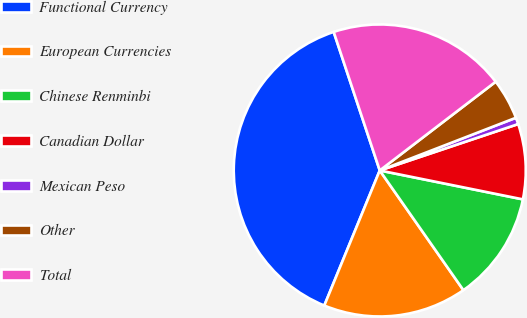<chart> <loc_0><loc_0><loc_500><loc_500><pie_chart><fcel>Functional Currency<fcel>European Currencies<fcel>Chinese Renminbi<fcel>Canadian Dollar<fcel>Mexican Peso<fcel>Other<fcel>Total<nl><fcel>38.69%<fcel>15.91%<fcel>12.12%<fcel>8.32%<fcel>0.73%<fcel>4.52%<fcel>19.71%<nl></chart> 